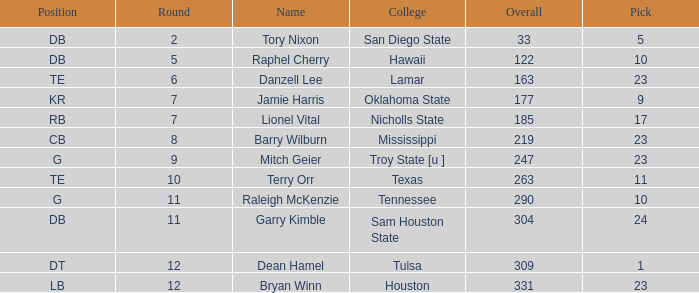Which Round is the highest one that has a Pick smaller than 10, and a Name of tory nixon? 2.0. 